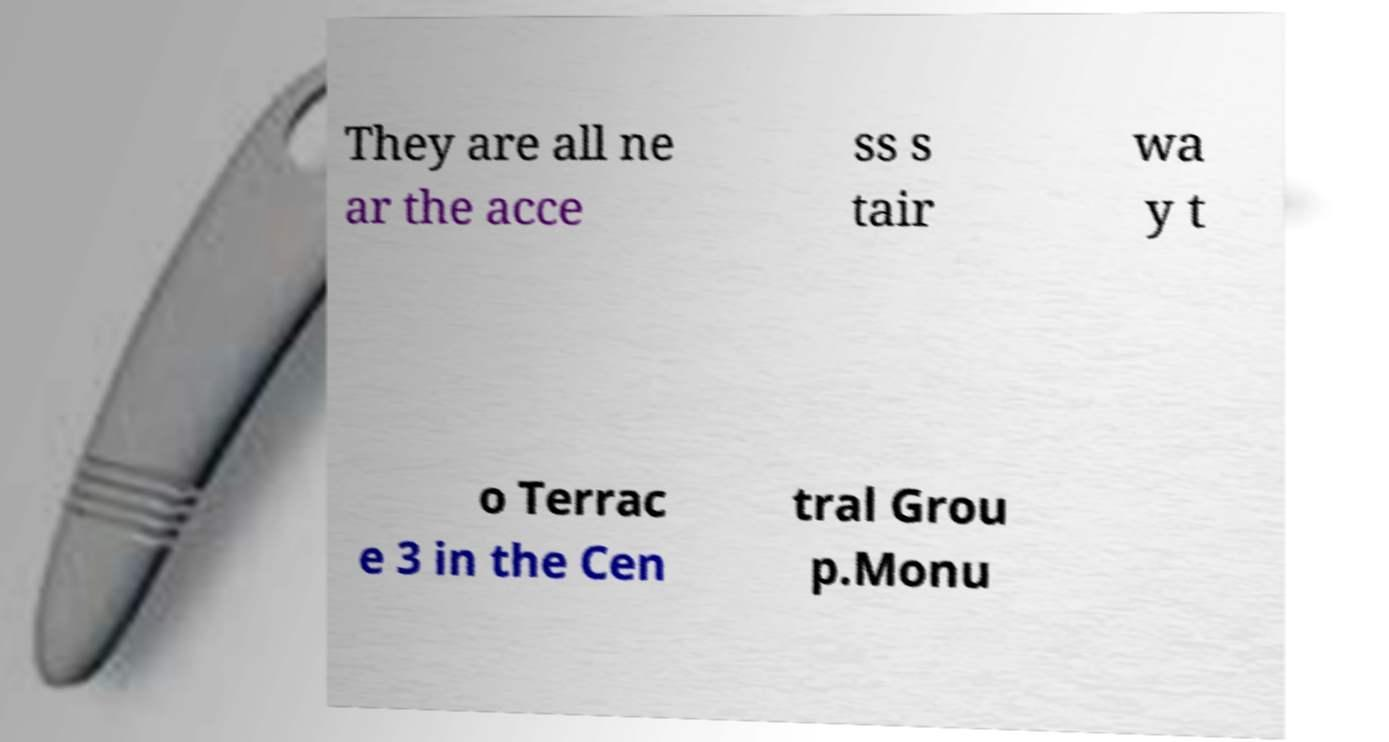Could you extract and type out the text from this image? They are all ne ar the acce ss s tair wa y t o Terrac e 3 in the Cen tral Grou p.Monu 